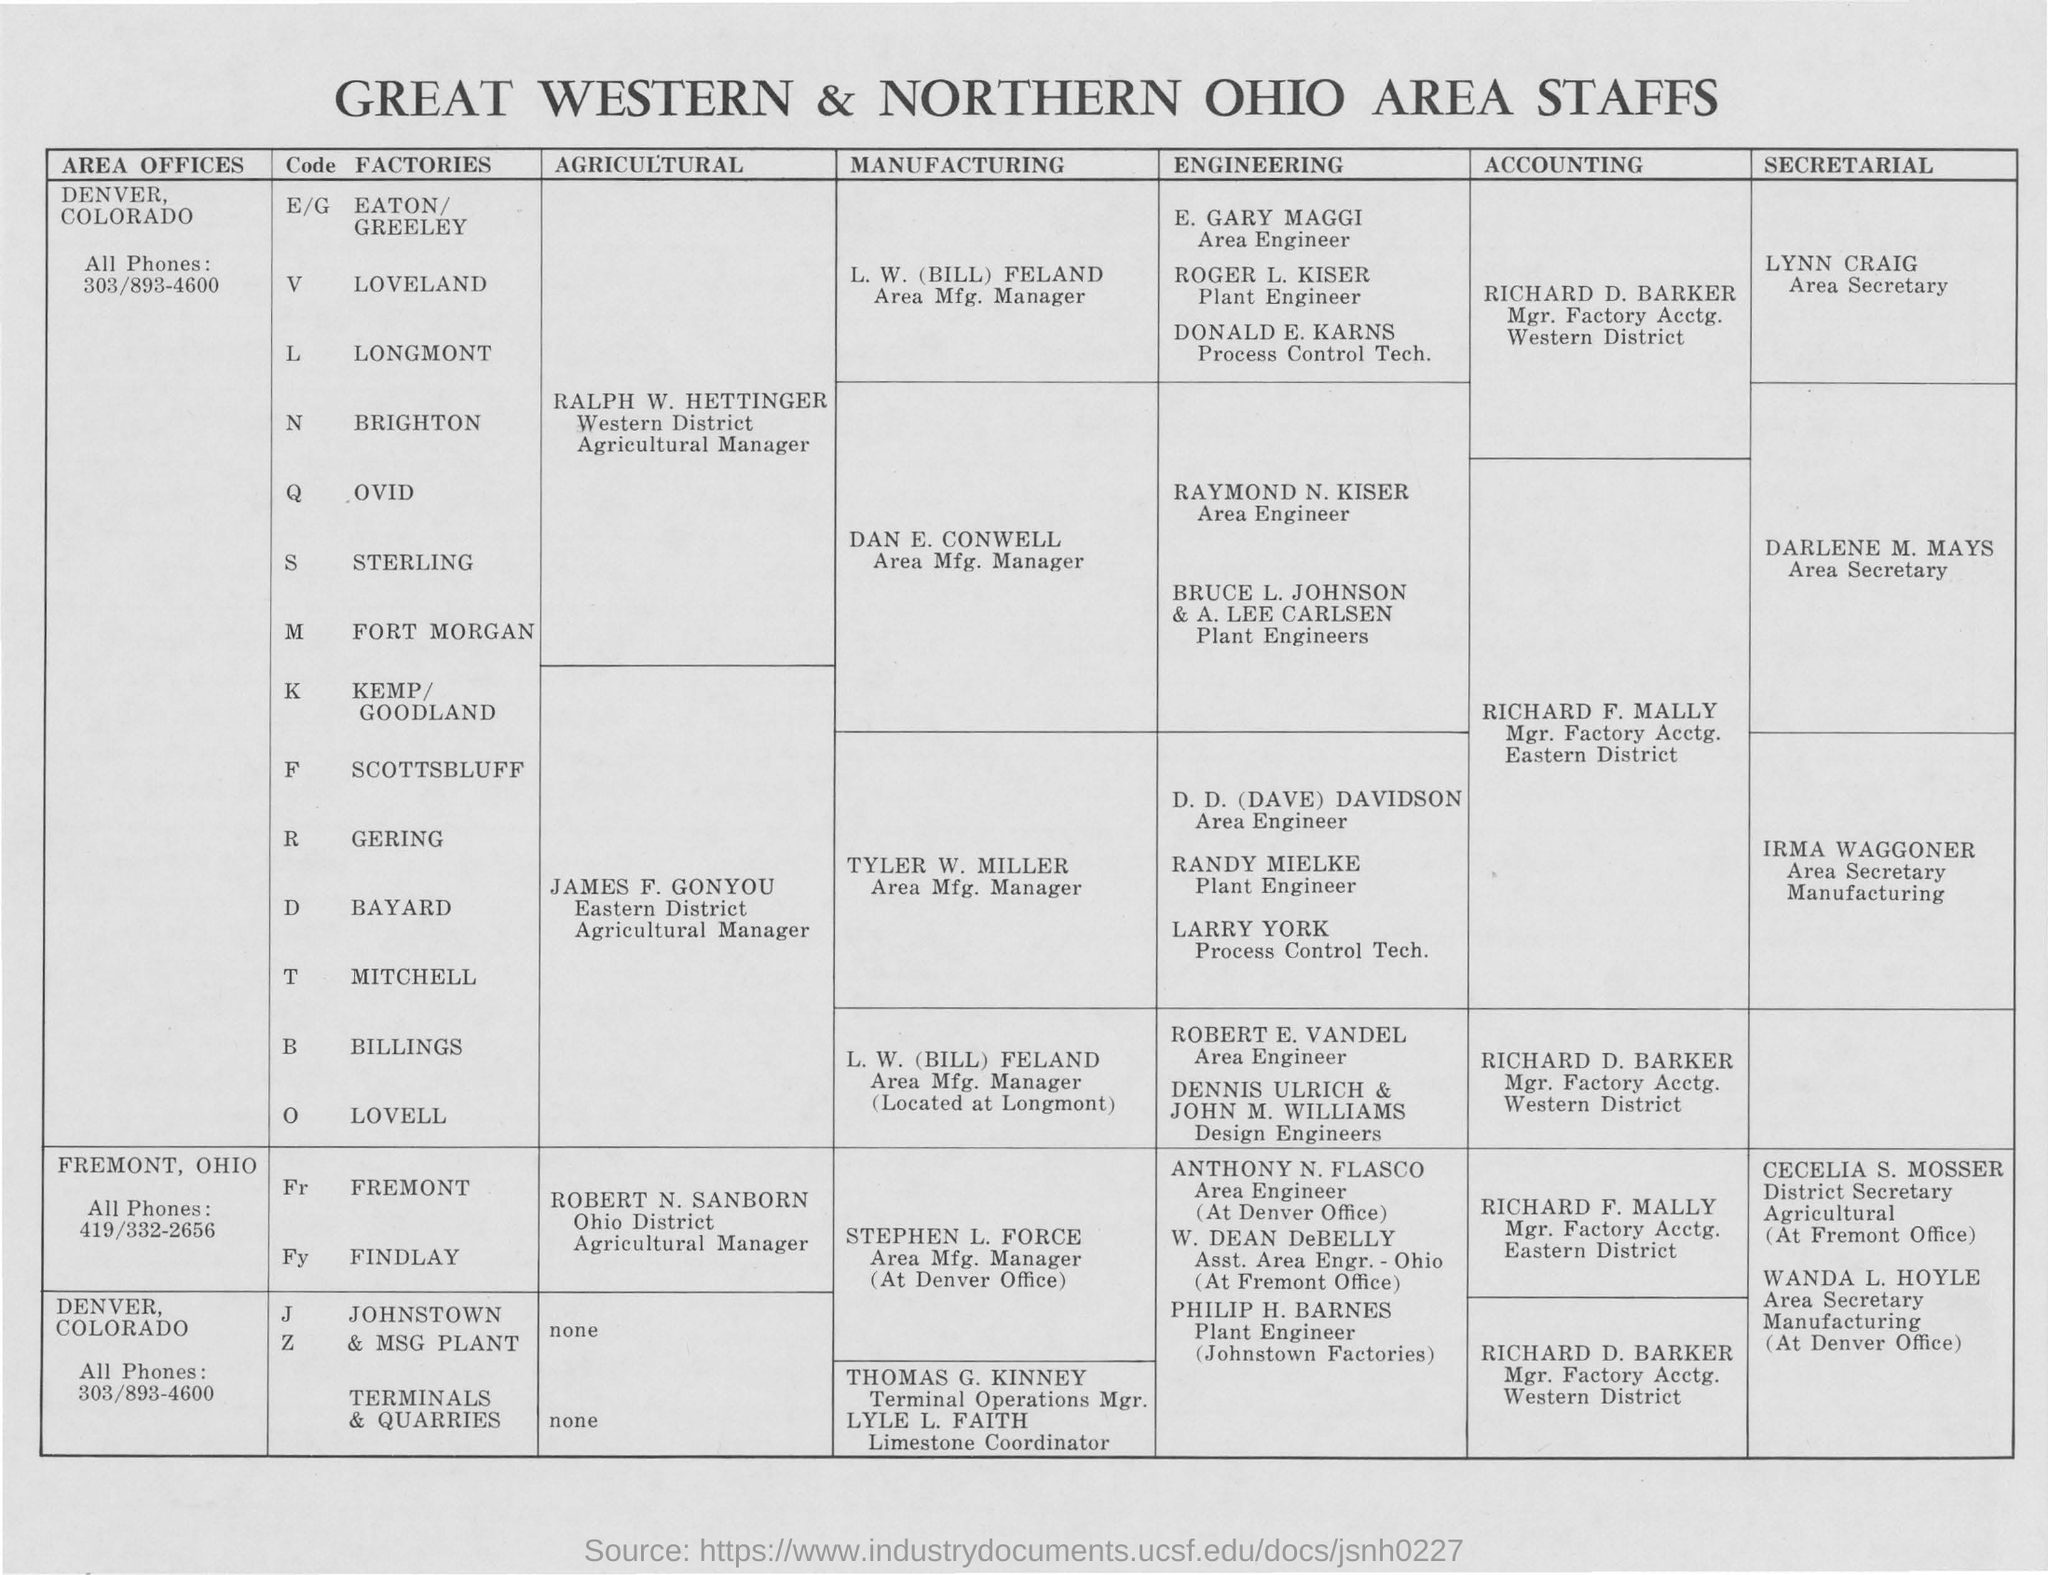Mention a couple of crucial points in this snapshot. ROBERT N. SANBORN is designated as the agriculture manager for the Fremont Ohio district of the Findlay factory. The document contains information regarding the staff of the Great Western & Northern Ohio Area. Raymond N. Kiser has been designated as the area engineer for the Ovid company. The individual named William Dean DeBelly is designated as the Assistant Area Engineer of Ohio at the Fremont office. The manager responsible for accounting at the eastern district of Greing factory is Richard F. Mally. 